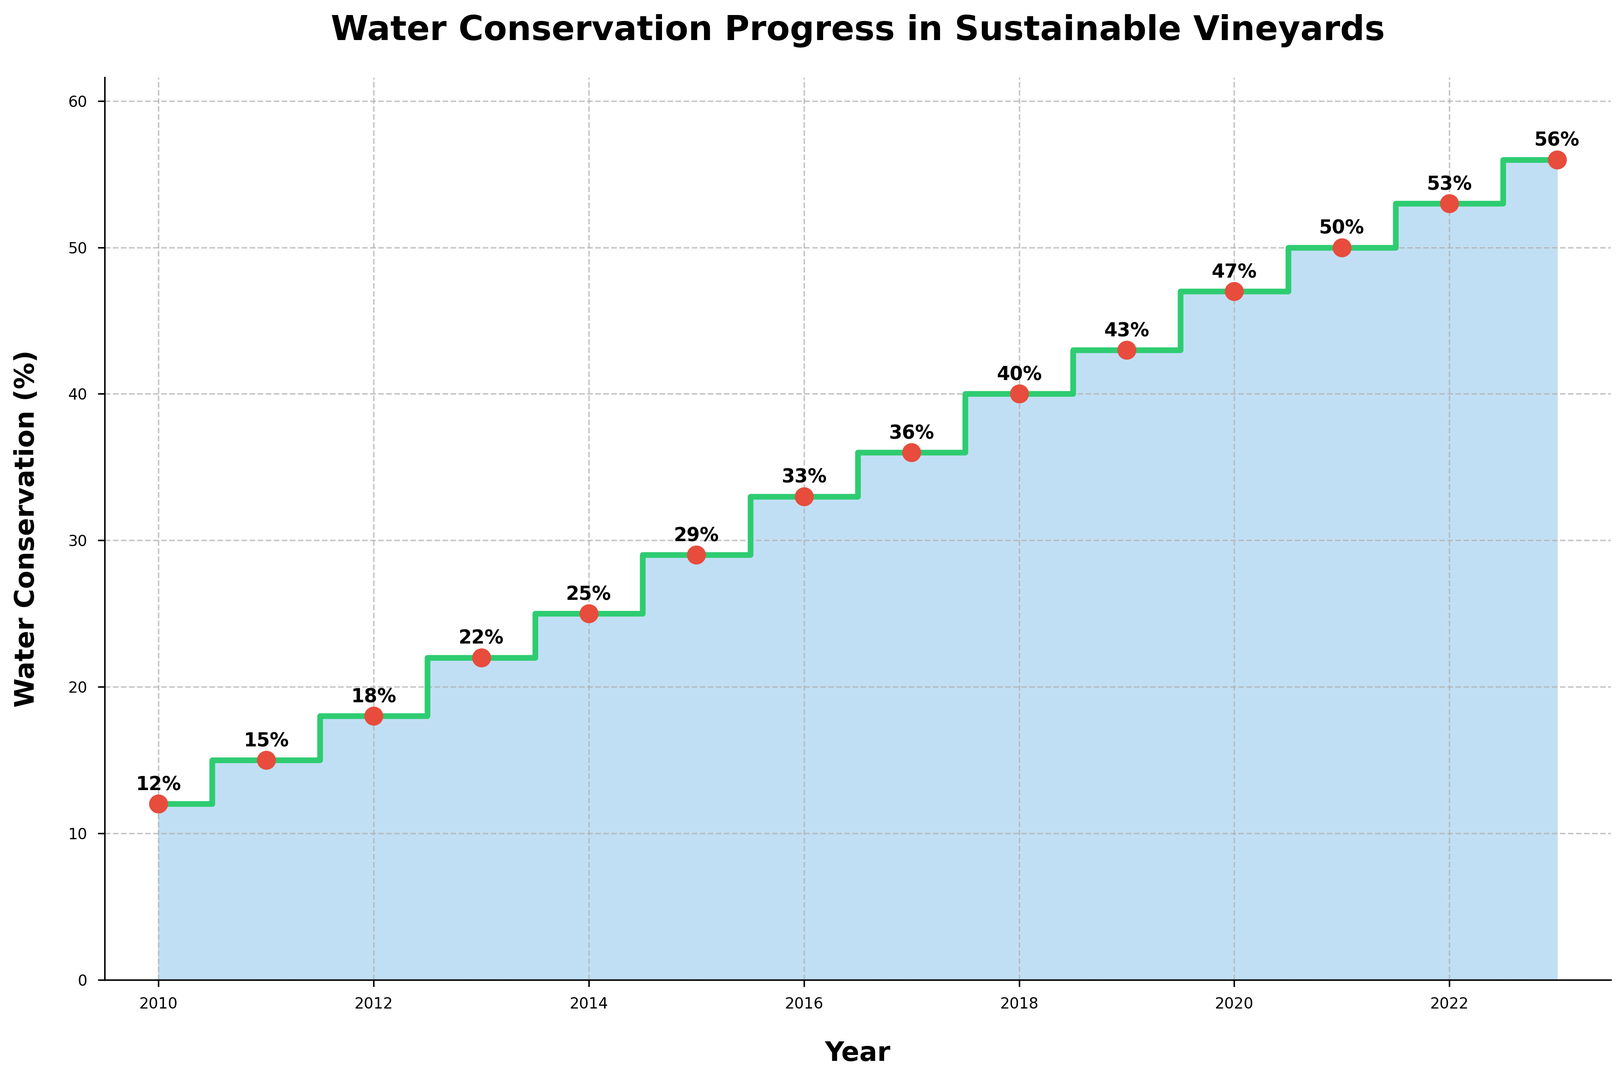What year did vineyards first achieve more than 20% water conservation? By examining the steps in the plot, the year where the percentage first surpasses 20% is in 2013.
Answer: 2013 How much did the water conservation percentage increase from 2010 to 2023? The percentage in 2010 is 12% and in 2023 it is 56%. The increase is calculated as 56% - 12% = 44%.
Answer: 44% Which year shows the highest improvement in water conservation from the previous year? By looking at the intervals between each point on the plot, we can see the differences between consecutive years. The highest increase is from 2019 (43%) to 2020 (47%), which is 4%.
Answer: 2020 What is the average water conservation percentage from 2010 to 2015? The percentages from 2010 to 2015 are 12%, 15%, 18%, 22%, 25%, and 29%. The average is calculated as (12+15+18+22+25+29) / 6 = 20.17%.
Answer: 20.17% In which year did water conservation reach halfway to the 2023 level? 2023’s level is 56%; halfway is 28%. By checking the plot, 2015 reaches 29%, which is the first point to meet or surpass halfway to 56%.
Answer: 2015 How much did the water conservation percentage increase from 2016 to 2018? The water conservation percentage in 2016 is 33%, and in 2018, it is 40%. Therefore, the increase is 40% - 33% = 7%.
Answer: 7% Compare water conservation percentages between 2011 and 2016. The water conservation in 2011 is 15%, whereas it is 33% in 2016. Thus, 2016 has a higher percentage.
Answer: 2016 How many years have associations between the markers and their values shown on the plot? By counting the annotated markers on the plot, we can see that all years from 2010 to 2023 are annotated, totaling 14 years.
Answer: 14 Which year had a 36% water conservation percentage? Following the plot, the year with a 36% water conservation percentage is 2017.
Answer: 2017 What color is used to represent the filled area beneath the step plot? The filled area beneath the step plot is visually represented using a blue color.
Answer: Blue 